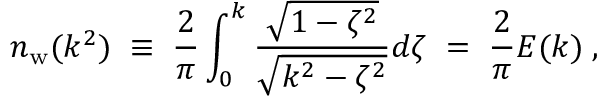Convert formula to latex. <formula><loc_0><loc_0><loc_500><loc_500>n _ { w } ( k ^ { 2 } ) \, \equiv \, { \frac { 2 } { \pi } } \int _ { 0 } ^ { k } { \frac { \sqrt { 1 - \zeta ^ { 2 } } } { \sqrt { k ^ { 2 } - \zeta ^ { 2 } } } } d \zeta \, = \, { \frac { 2 } { \pi } } E ( k ) \, ,</formula> 